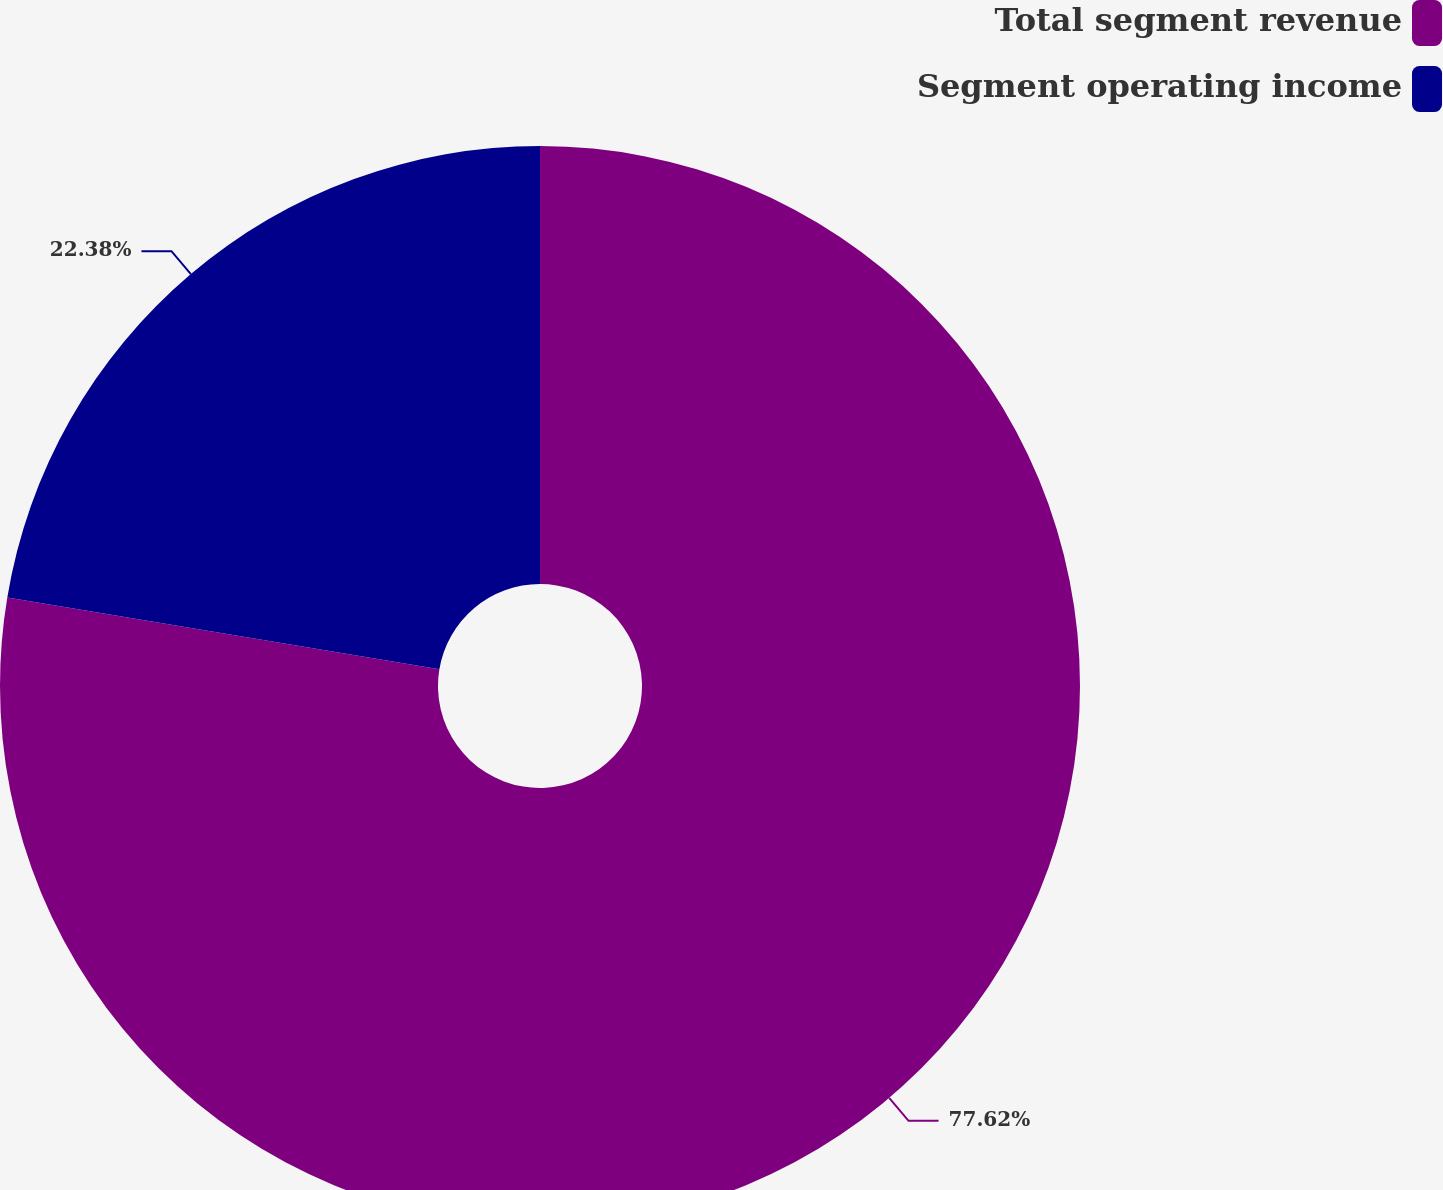Convert chart. <chart><loc_0><loc_0><loc_500><loc_500><pie_chart><fcel>Total segment revenue<fcel>Segment operating income<nl><fcel>77.62%<fcel>22.38%<nl></chart> 